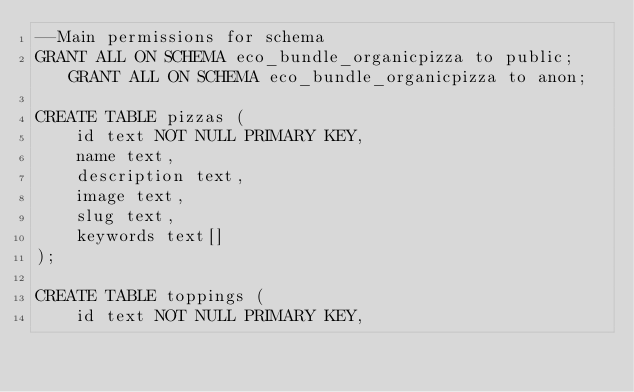<code> <loc_0><loc_0><loc_500><loc_500><_SQL_>--Main permissions for schema
GRANT ALL ON SCHEMA eco_bundle_organicpizza to public; GRANT ALL ON SCHEMA eco_bundle_organicpizza to anon;

CREATE TABLE pizzas (
    id text NOT NULL PRIMARY KEY,
    name text,
    description text,
    image text,
    slug text,
    keywords text[]
);

CREATE TABLE toppings (
    id text NOT NULL PRIMARY KEY,</code> 